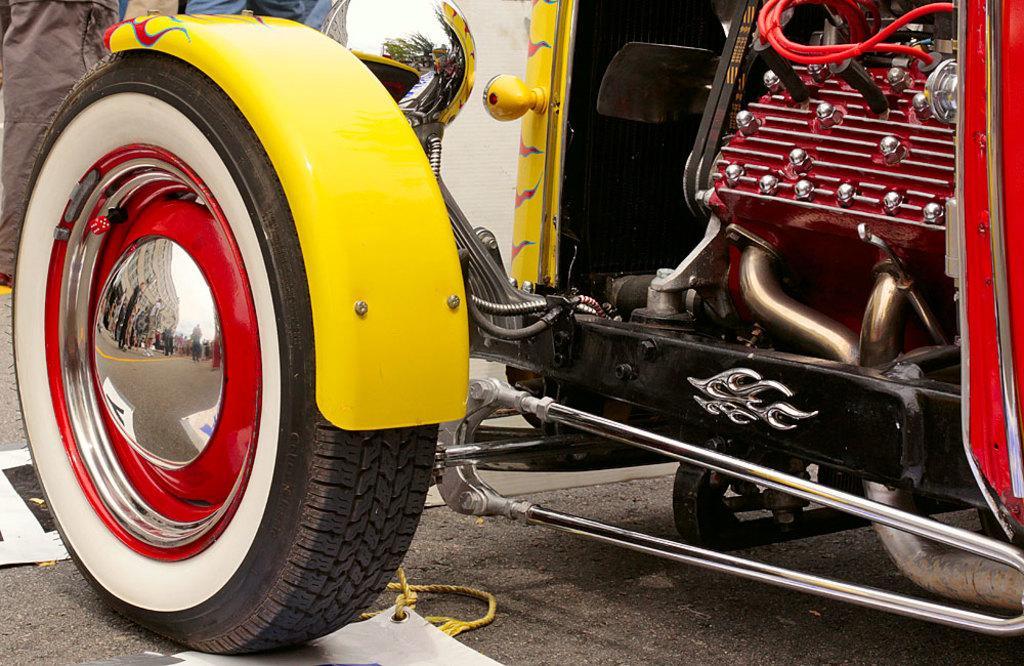How would you summarize this image in a sentence or two? In this image I can see a vehicle which is yellow, white , red and black in color on the ground. In the background I can see few persons and on the vehicle I can see the reflection of few persons standing, few buildings, few trees and the sky. 